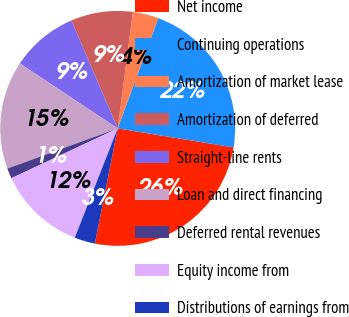Convert chart to OTSL. <chart><loc_0><loc_0><loc_500><loc_500><pie_chart><fcel>Net income<fcel>Continuing operations<fcel>Amortization of market lease<fcel>Amortization of deferred<fcel>Straight-line rents<fcel>Loan and direct financing<fcel>Deferred rental revenues<fcel>Equity income from<fcel>Distributions of earnings from<nl><fcel>25.53%<fcel>21.98%<fcel>3.55%<fcel>8.51%<fcel>9.22%<fcel>14.89%<fcel>1.42%<fcel>12.06%<fcel>2.84%<nl></chart> 